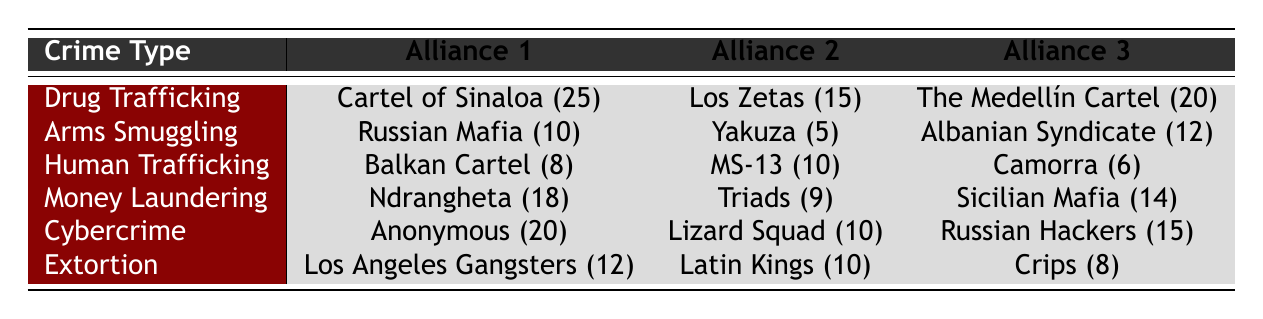What is the total number of alliances involved in Drug Trafficking? There are three alliances listed under Drug Trafficking: Cartel of Sinaloa, Los Zetas, and The Medellín Cartel. Counting them gives us a total of 3 alliances.
Answer: 3 Which alliance has the highest association with Cybercrime? Under Cybercrime, the alliances are Anonymous (20), Lizard Squad (10), and Russian Hackers (15). The highest association is with Anonymous at 20.
Answer: Anonymous Is there any alliance associated with Human Trafficking that also appears in other crime categories? The alliances listed for Human Trafficking are Balkan Cartel (8), MS-13 (10), and Camorra (6). MS-13 appears in other crime types (specifically, it often associates with other gangs) but isn't explicitly listed here, so the answer is no as per this table.
Answer: No What is the average number of alliances per crime type? There are 6 crime types in total, and each crime type has exactly 3 alliances listed, thus the total number of alliances is 3 * 6 = 18. The average number of alliances per crime type is 18 / 6 = 3.
Answer: 3 Which crime type has the lowest overall number of alliances, and what is that number? By examining the alliances related to each crime type, we can see that all crime types have 3 alliances. Thus, no crime type has a lower number of alliances than the others, so they all share the same count.
Answer: 3 How many alliances are there in total for Money Laundering and Arms Smuggling combined? For Money Laundering, the alliances are Ndrangheta (18), Triads (9), and Sicilian Mafia (14), giving a total of 3. For Arms Smuggling, we have Russian Mafia (10), Yakuza (5), and Albanian Syndicate (12), also giving a total of 3. Therefore, the combined total for both is 3 + 3 = 6.
Answer: 6 Is the number of alliances in Extortion greater than the number of alliances in Human Trafficking? Both Extortion (Los Angeles Gangsters 12, Latin Kings 10, Crips 8) and Human Trafficking (Balkan Cartel 8, MS-13 10, Camorra 6) have 3 alliances. Thus, neither has a greater number.
Answer: No Which alliance in Money Laundering has an association of 18? The alliances listed are Ndrangheta (18), Triads (9), and Sicilian Mafia (14). The alliance with the association of 18 is Ndrangheta.
Answer: Ndrangheta 